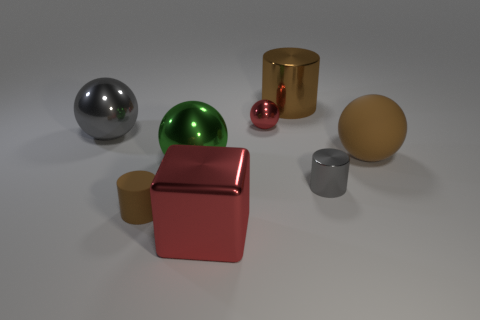Is the number of small cyan shiny cubes greater than the number of big red blocks?
Make the answer very short. No. Do the big matte ball and the small cylinder left of the large metal block have the same color?
Make the answer very short. Yes. The large metallic thing that is both behind the large brown rubber sphere and in front of the big brown metallic cylinder is what color?
Your answer should be compact. Gray. How many other objects are there of the same material as the tiny brown cylinder?
Your response must be concise. 1. Is the number of big green metal objects less than the number of cyan cylinders?
Your answer should be very brief. No. Are the tiny brown cylinder and the gray object that is on the left side of the brown shiny cylinder made of the same material?
Offer a very short reply. No. There is a gray metal object left of the small matte cylinder; what shape is it?
Your answer should be very brief. Sphere. Is there anything else that is the same color as the big rubber thing?
Give a very brief answer. Yes. Are there fewer small brown objects that are right of the rubber cylinder than matte things?
Make the answer very short. Yes. What number of cyan metallic cylinders have the same size as the gray sphere?
Provide a short and direct response. 0. 